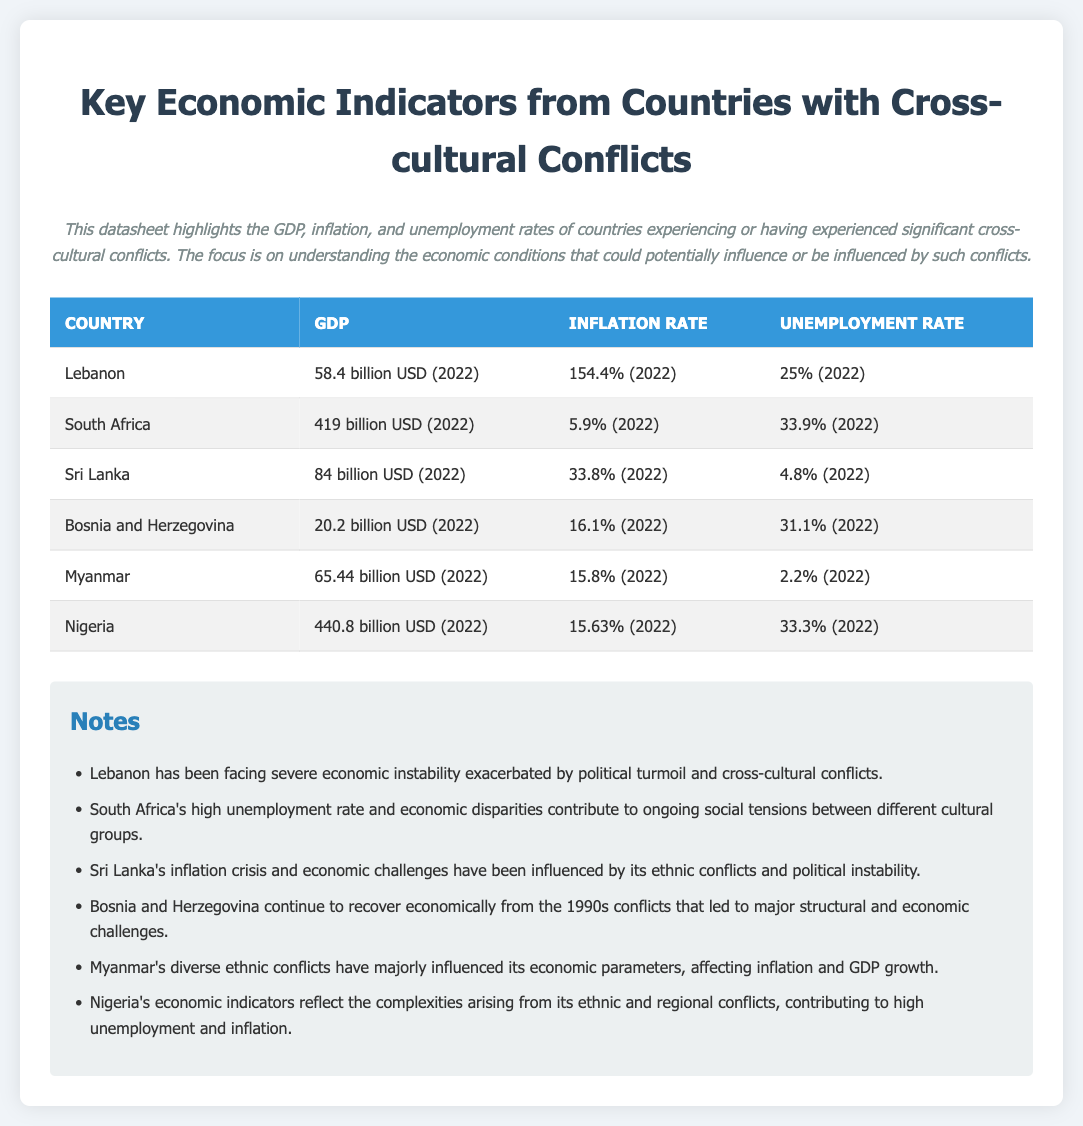What is the GDP of Lebanon? The GDP of Lebanon is listed in the document as 58.4 billion USD for the year 2022.
Answer: 58.4 billion USD (2022) What is the unemployment rate in South Africa? The unemployment rate for South Africa is provided in the document as 33.9% for the year 2022.
Answer: 33.9% (2022) Which country has the highest inflation rate? The document shows that Lebanon has the highest inflation rate at 154.4% for the year 2022.
Answer: 154.4% (2022) What economic condition is Sri Lanka facing? The document notes that Sri Lanka is experiencing an inflation crisis and economic challenges influenced by ethnic conflicts.
Answer: Inflation crisis What does the document note about Bosnia and Herzegovina's economy? The document mentions that Bosnia and Herzegovina continues to recover economically from the conflicts of the 1990s, with ongoing structural and economic challenges.
Answer: Recovery from 1990s conflicts How does Nigeria's economic indicators relate to its conflicts? It states that Nigeria's economic indicators reflect complexities arising from ethnic and regional conflicts leading to high unemployment and inflation.
Answer: High unemployment and inflation What year is the data for Myanmar from? The data for Myanmar is provided as being from 2022 in the document.
Answer: 2022 What is the primary focus of the datasheet? The primary focus of the datasheet is on understanding economic conditions influenced by significant cross-cultural conflicts.
Answer: Economic conditions influenced by cross-cultural conflicts How many countries are listed in the datasheet? The datasheet lists a total of six countries experiencing or having experienced cross-cultural conflicts and their economic indicators.
Answer: Six countries 